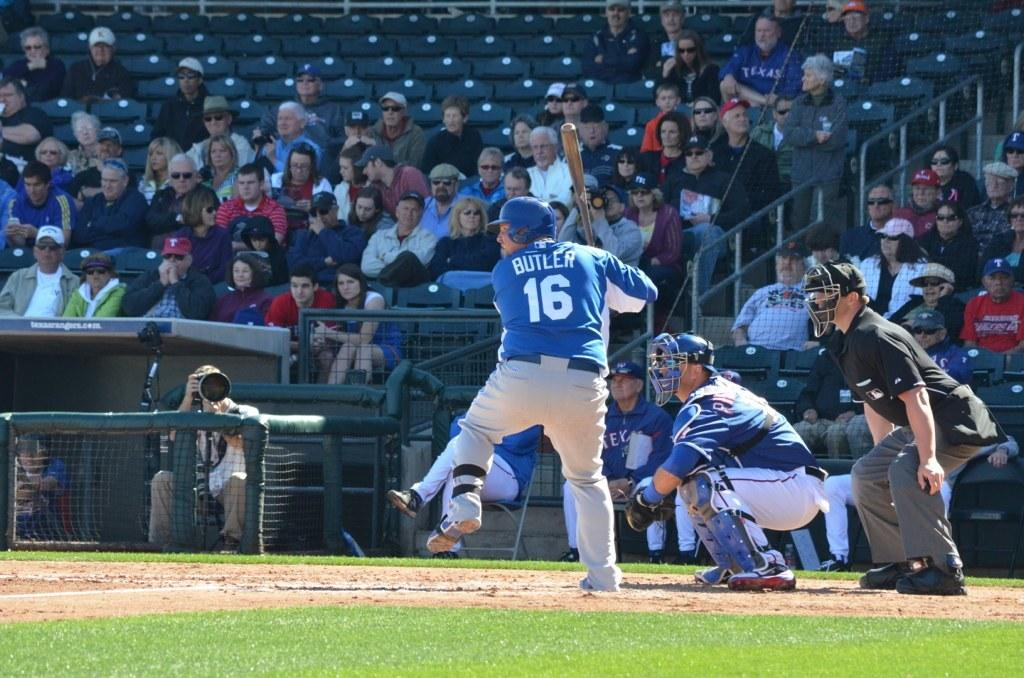<image>
Present a compact description of the photo's key features. A man in a white and blue baseball uniform with the number 16 on his back is about to swing his bat. 